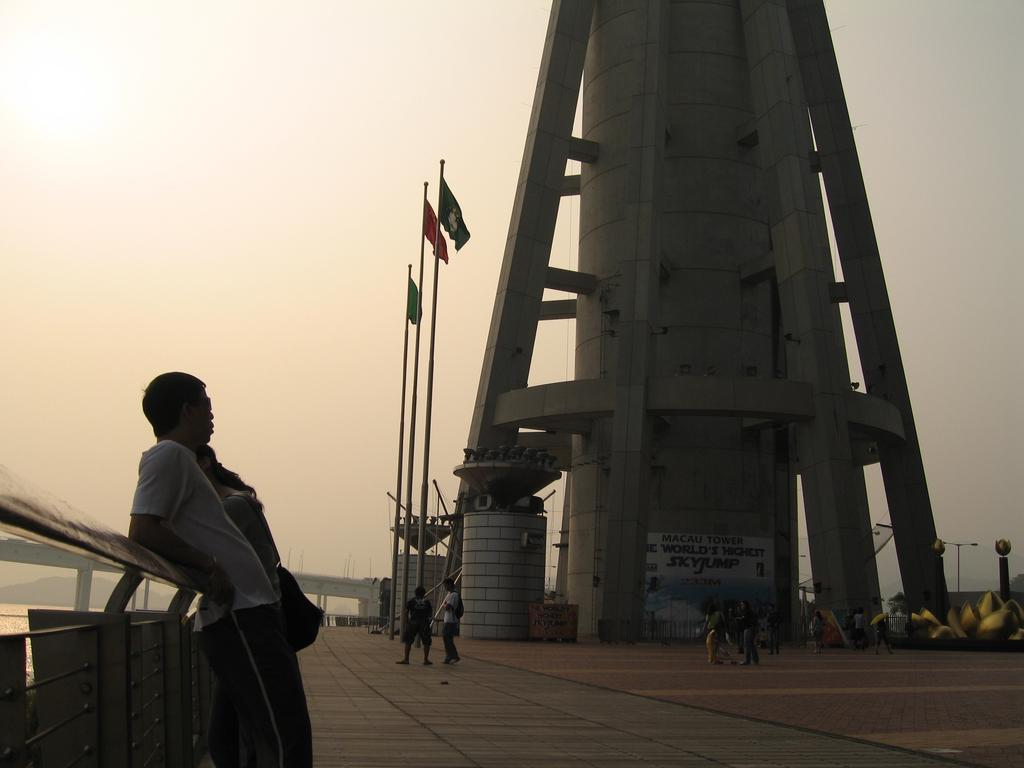How many people are in the image? There is a group of people standing in the image. What structure can be seen in the image? There is a tower in the image. What are the flags attached to in the image? There are flags with poles in the image. What feature is present in the image that connects two areas? There is a bridge in the image. What natural element is visible in the image? There is water visible in the image. What can be seen in the background of the image? The sky is visible in the background of the image. Where is the shelf located in the image? There is no shelf present in the image. How many deer can be seen in the image? There are no deer present in the image. 